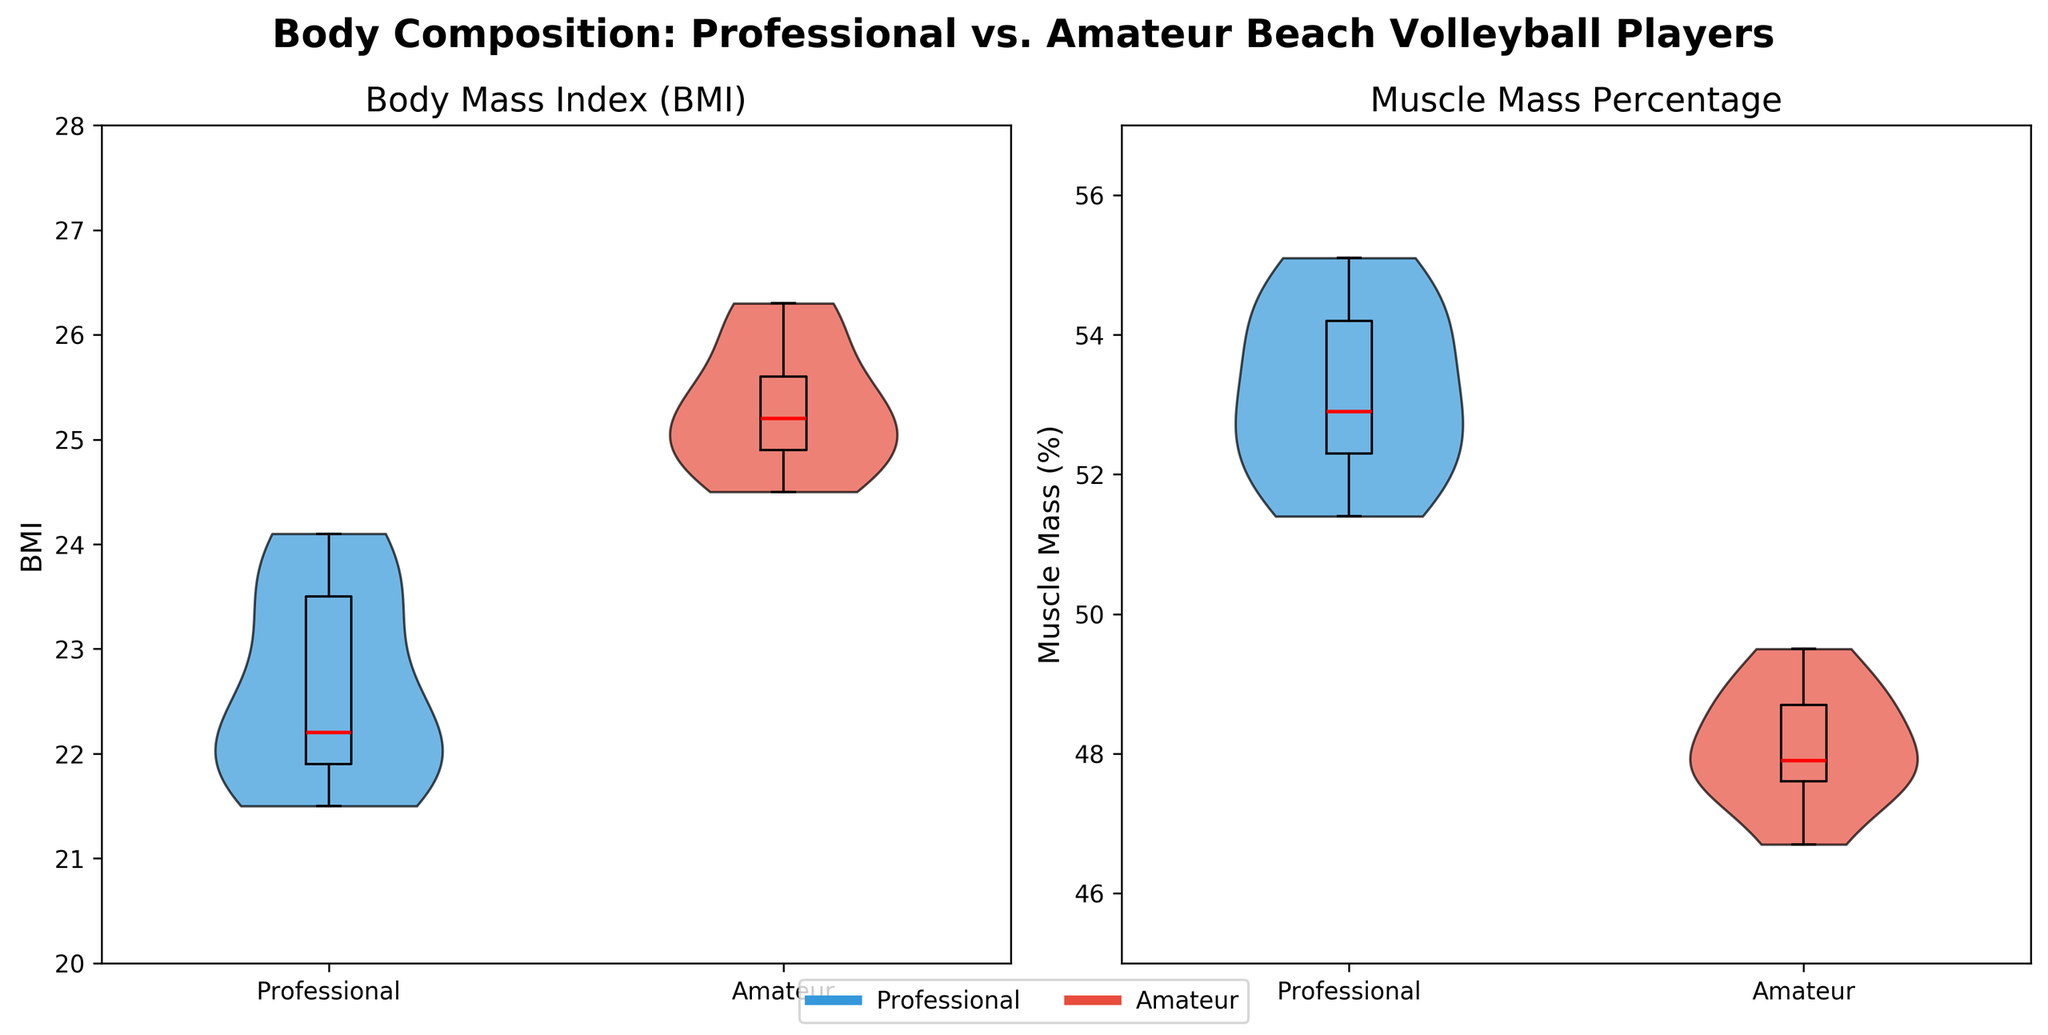what is the title of the figure? The title is displayed at the top of the figure. It reads "Body Composition: Professional vs. Amateur Beach Volleyball Players."
Answer: Body Composition: Professional vs. Amateur Beach Volleyball Players How many groups are compared in each subplot? There are two groups compared in each subplot, as indicated by the two violins and box plots on either side.
Answer: Two Which group has a higher median BMI? The box plot overlay shows a red line for the median value. The median line for the Amateur group is higher than that of the Professional group.
Answer: Amateur group What are the y-axis labels for the BMI and Muscle Mass Percentage plots, respectively? The y-axis labels are shown on the left side of each subplot. For the BMI plot, it says "BMI," and for the Muscle Mass Percentage plot, it says "Muscle Mass (%)."
Answer: BMI; Muscle Mass (%) Between the Professional and Amateur groups, which one shows a wider range in Muscle Mass Percentage? The width of the violins and the spread of the box plots indicate the range. The Amateur group has a wider violin shape and a more spread out box plot in the Muscle Mass Percentage plot.
Answer: Amateur group What color represents the Professional group in the figure? The legend at the bottom of the figure shows the colors. The Professional group is represented in blue.
Answer: Blue Which plot has a lower lower-end value for the Professional group's data, BMI or Muscle Mass Percentage? The lower end of the violin and box plot for BMI is about 21.5 for the Professional group, whereas the lower end for Muscle Mass Percentage is about 51%. Therefore, the Muscle Mass Percentage has a lower end value.
Answer: Muscle Mass Percentage Is the median muscle mass percentage of the Professional group above or below 53%? The red median line in the Muscle Mass Percentage plot shows that the median muscle mass for the Professional group is slightly above 53%.
Answer: Above 53% What is the approximate range of BMI values for the Amateur group? By looking at the width of the violin plot and the spread of the box plot, we notice that the BMI values range from about 24.5 to 26.3 for the Amateur group.
Answer: 24.5 to 26.3 How do the distributions of muscle mass percentage differ between Professional and Amateur players? The distribution for Professionals is more concentrated and higher, while the distribution for Amateurs is wider and lower, as indicated by the shapes of the violin plots and positions of the box plots.
Answer: Professionals are more concentrated and higher; Amateurs are wider and lower 